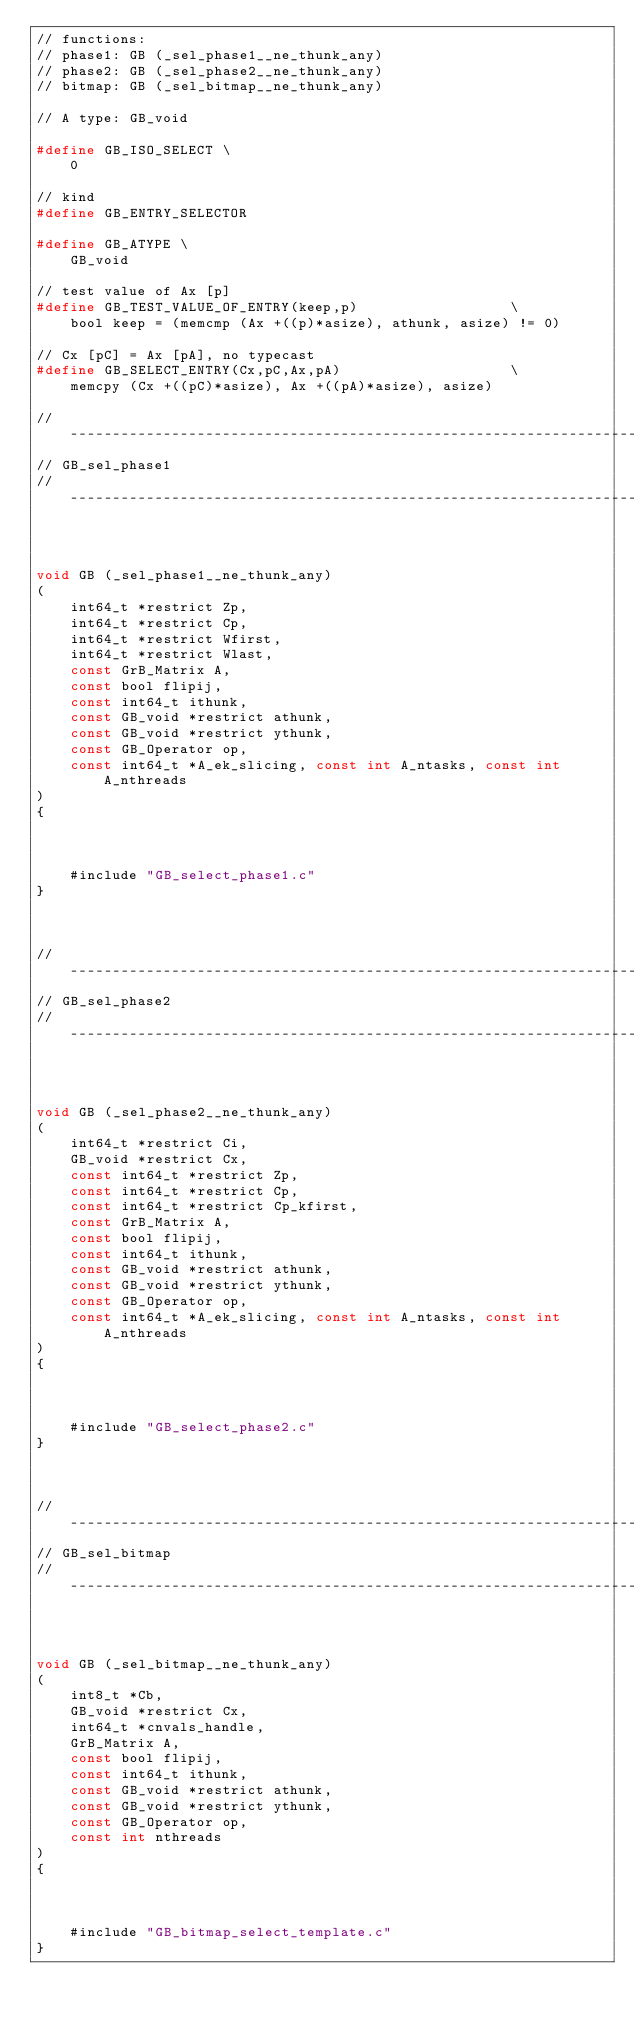<code> <loc_0><loc_0><loc_500><loc_500><_C_>// functions:
// phase1: GB (_sel_phase1__ne_thunk_any)
// phase2: GB (_sel_phase2__ne_thunk_any)
// bitmap: GB (_sel_bitmap__ne_thunk_any)

// A type: GB_void

#define GB_ISO_SELECT \
    0

// kind
#define GB_ENTRY_SELECTOR

#define GB_ATYPE \
    GB_void

// test value of Ax [p]
#define GB_TEST_VALUE_OF_ENTRY(keep,p)                  \
    bool keep = (memcmp (Ax +((p)*asize), athunk, asize) != 0)

// Cx [pC] = Ax [pA], no typecast
#define GB_SELECT_ENTRY(Cx,pC,Ax,pA)                    \
    memcpy (Cx +((pC)*asize), Ax +((pA)*asize), asize)

//------------------------------------------------------------------------------
// GB_sel_phase1
//------------------------------------------------------------------------------



void GB (_sel_phase1__ne_thunk_any)
(
    int64_t *restrict Zp,
    int64_t *restrict Cp,
    int64_t *restrict Wfirst,
    int64_t *restrict Wlast,
    const GrB_Matrix A,
    const bool flipij,
    const int64_t ithunk,
    const GB_void *restrict athunk,
    const GB_void *restrict ythunk,
    const GB_Operator op,
    const int64_t *A_ek_slicing, const int A_ntasks, const int A_nthreads
)
{ 
    
    
    
    #include "GB_select_phase1.c"
}



//------------------------------------------------------------------------------
// GB_sel_phase2
//------------------------------------------------------------------------------



void GB (_sel_phase2__ne_thunk_any)
(
    int64_t *restrict Ci,
    GB_void *restrict Cx,
    const int64_t *restrict Zp,
    const int64_t *restrict Cp,
    const int64_t *restrict Cp_kfirst,
    const GrB_Matrix A,
    const bool flipij,
    const int64_t ithunk,
    const GB_void *restrict athunk,
    const GB_void *restrict ythunk,
    const GB_Operator op,
    const int64_t *A_ek_slicing, const int A_ntasks, const int A_nthreads
)
{ 
    
    
    
    #include "GB_select_phase2.c"
}



//------------------------------------------------------------------------------
// GB_sel_bitmap
//------------------------------------------------------------------------------



void GB (_sel_bitmap__ne_thunk_any)
(
    int8_t *Cb,
    GB_void *restrict Cx,
    int64_t *cnvals_handle,
    GrB_Matrix A,
    const bool flipij,
    const int64_t ithunk,
    const GB_void *restrict athunk,
    const GB_void *restrict ythunk,
    const GB_Operator op,
    const int nthreads
)
{ 
    
    
    
    #include "GB_bitmap_select_template.c"
}


</code> 